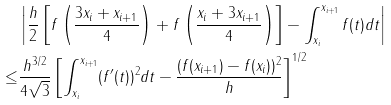Convert formula to latex. <formula><loc_0><loc_0><loc_500><loc_500>& \left | \frac { h } { 2 } \left [ f \left ( \frac { 3 x _ { i } + x _ { i + 1 } } { 4 } \right ) + f \left ( \frac { x _ { i } + 3 x _ { i + 1 } } { 4 } \right ) \right ] - \int _ { x _ { i } } ^ { x _ { i + 1 } } f ( t ) d t \right | \\ \leq & \frac { h ^ { 3 / 2 } } { 4 \sqrt { 3 } } \left [ \int _ { x _ { i } } ^ { x _ { i + 1 } } ( f ^ { \prime } ( t ) ) ^ { 2 } d t - \frac { ( f ( x _ { i + 1 } ) - f ( x _ { i } ) ) ^ { 2 } } { h } \right ] ^ { 1 / 2 }</formula> 